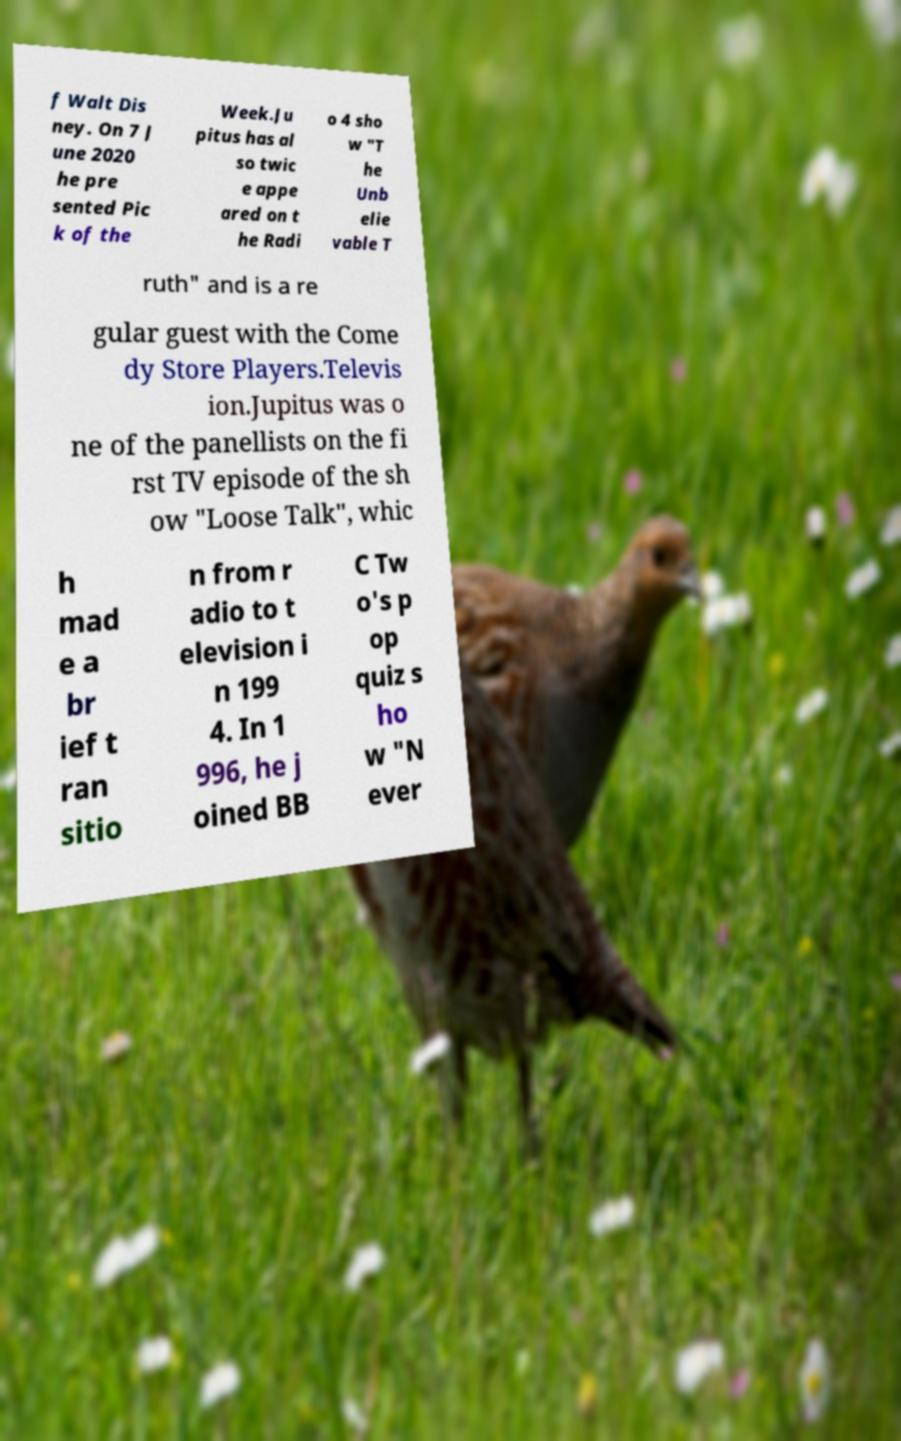Please read and relay the text visible in this image. What does it say? f Walt Dis ney. On 7 J une 2020 he pre sented Pic k of the Week.Ju pitus has al so twic e appe ared on t he Radi o 4 sho w "T he Unb elie vable T ruth" and is a re gular guest with the Come dy Store Players.Televis ion.Jupitus was o ne of the panellists on the fi rst TV episode of the sh ow "Loose Talk", whic h mad e a br ief t ran sitio n from r adio to t elevision i n 199 4. In 1 996, he j oined BB C Tw o's p op quiz s ho w "N ever 